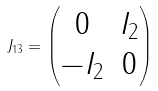<formula> <loc_0><loc_0><loc_500><loc_500>J _ { 1 3 } = \begin{pmatrix} 0 & I _ { 2 } \\ - I _ { 2 } & 0 \end{pmatrix}</formula> 